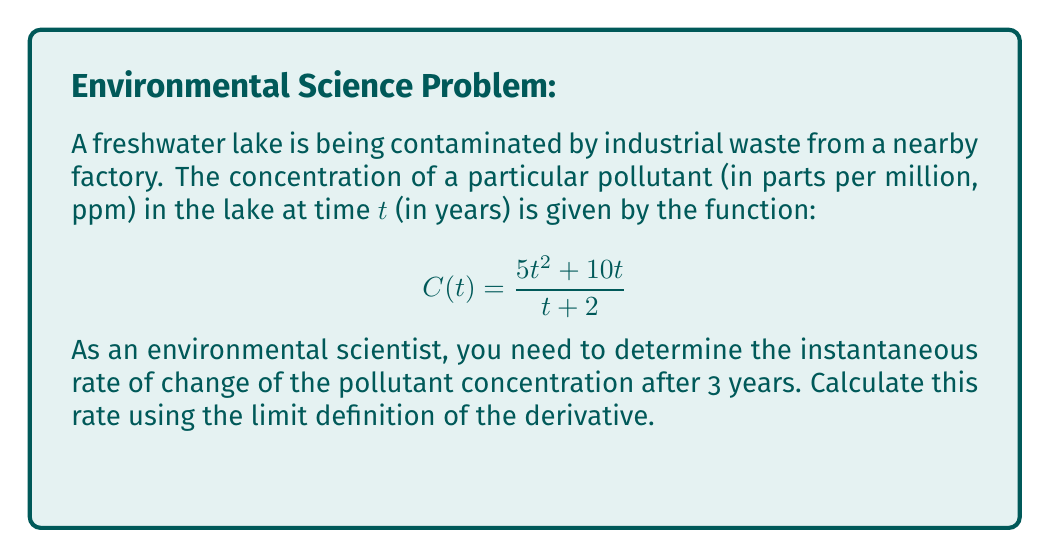Could you help me with this problem? To find the instantaneous rate of change at $t=3$, we need to calculate the derivative of $C(t)$ at $t=3$ using the limit definition:

$$C'(3) = \lim_{h \to 0} \frac{C(3+h) - C(3)}{h}$$

Step 1: Calculate $C(3)$
$$C(3) = \frac{5(3)^2 + 10(3)}{3 + 2} = \frac{45 + 30}{5} = 15$$

Step 2: Calculate $C(3+h)$
$$C(3+h) = \frac{5(3+h)^2 + 10(3+h)}{(3+h) + 2} = \frac{5(9+6h+h^2) + 30 + 10h}{5+h} = \frac{45 + 30h + 5h^2 + 30 + 10h}{5+h} = \frac{75 + 40h + 5h^2}{5+h}$$

Step 3: Set up the limit
$$\lim_{h \to 0} \frac{C(3+h) - C(3)}{h} = \lim_{h \to 0} \frac{\frac{75 + 40h + 5h^2}{5+h} - 15}{h}$$

Step 4: Simplify the numerator
$$\lim_{h \to 0} \frac{\frac{75 + 40h + 5h^2}{5+h} - \frac{75}{5}}{h} = \lim_{h \to 0} \frac{\frac{75 + 40h + 5h^2}{5+h} - \frac{75+15h}{5+h}}{h}$$
$$= \lim_{h \to 0} \frac{75 + 40h + 5h^2 - 75 - 15h}{(5+h)h} = \lim_{h \to 0} \frac{25h + 5h^2}{(5+h)h} = \lim_{h \to 0} \frac{25 + 5h}{5+h}$$

Step 5: Evaluate the limit
$$\lim_{h \to 0} \frac{25 + 5h}{5+h} = \frac{25}{5} = 5$$

Therefore, the instantaneous rate of change of the pollutant concentration after 3 years is 5 ppm/year.
Answer: 5 ppm/year 